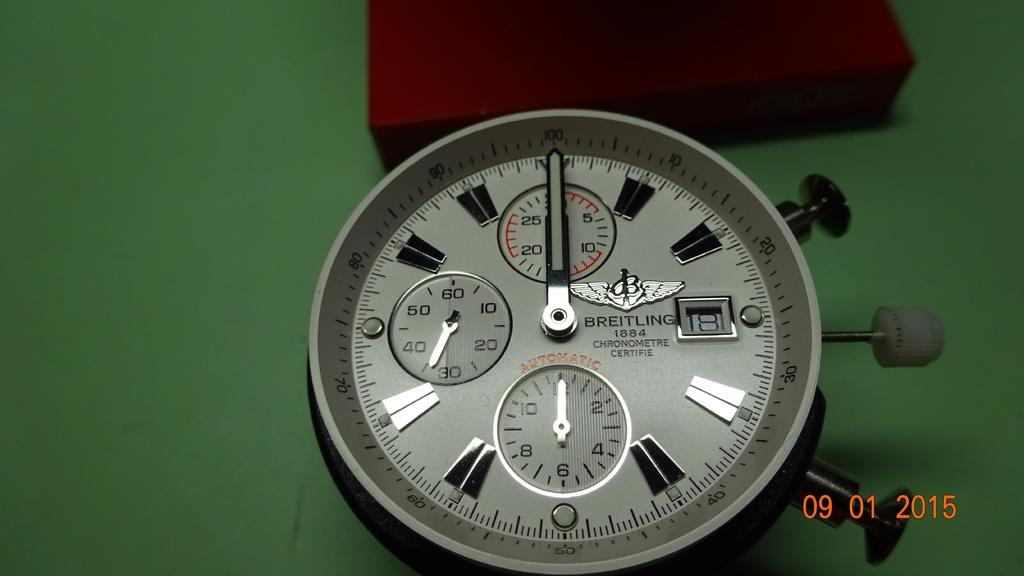<image>
Provide a brief description of the given image. Face of a white watch which has the brand name "Breitling" on it. 